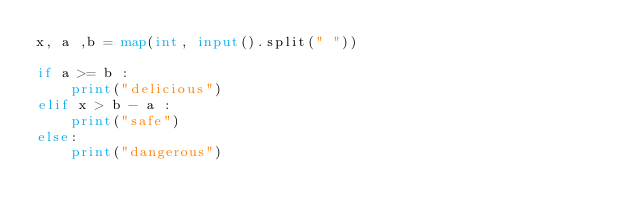<code> <loc_0><loc_0><loc_500><loc_500><_Python_>x, a ,b = map(int, input().split(" "))

if a >= b :
    print("delicious")
elif x > b - a :
    print("safe")
else:
    print("dangerous")
    
</code> 